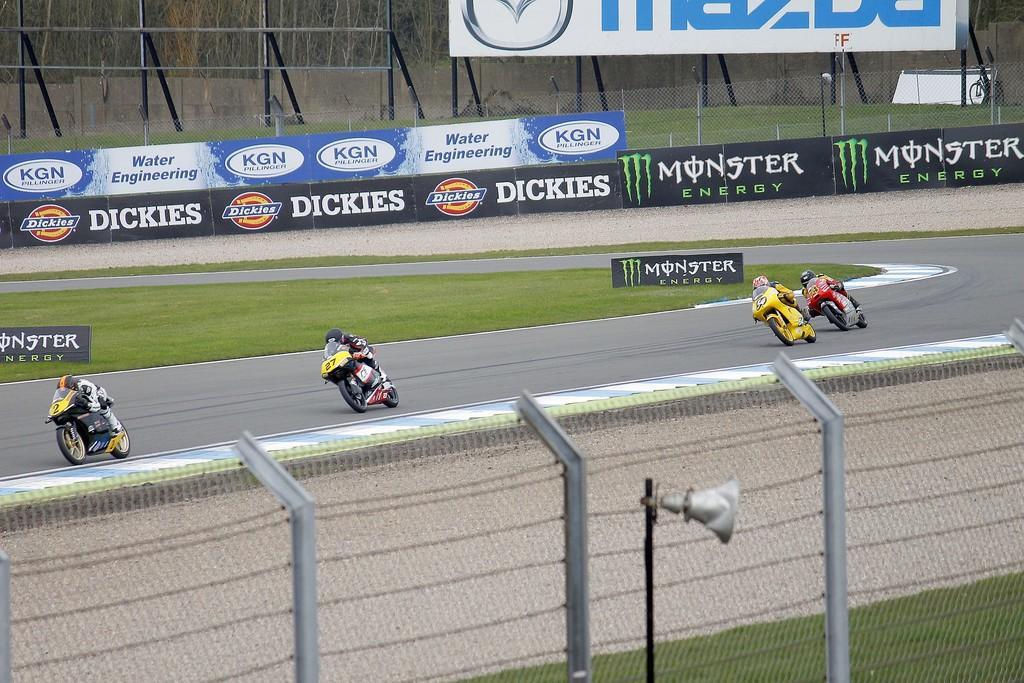How would you summarize this image in a sentence or two? At the bottom of the image there is fencing. On the road there are few people riding bikes. Behind them on the ground there is grass with posters. In the background there are posters with text and images. Behind them there is fencing. Behind the fencing there is a banner. Behind the banner there are trees. 